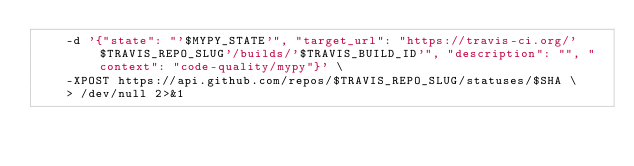<code> <loc_0><loc_0><loc_500><loc_500><_Bash_>    -d '{"state": "'$MYPY_STATE'", "target_url": "https://travis-ci.org/'$TRAVIS_REPO_SLUG'/builds/'$TRAVIS_BUILD_ID'", "description": "", "context": "code-quality/mypy"}' \
    -XPOST https://api.github.com/repos/$TRAVIS_REPO_SLUG/statuses/$SHA \
    > /dev/null 2>&1
</code> 